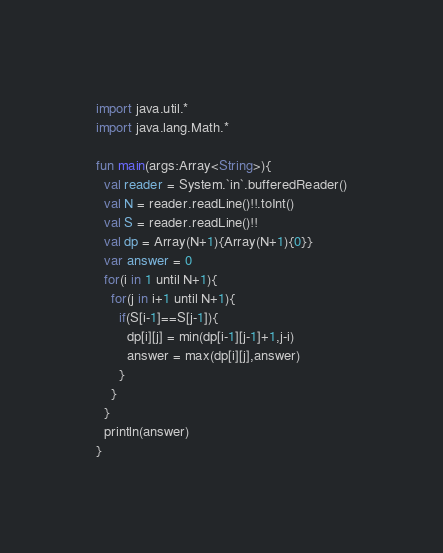<code> <loc_0><loc_0><loc_500><loc_500><_Kotlin_>import java.util.*
import java.lang.Math.*

fun main(args:Array<String>){
  val reader = System.`in`.bufferedReader()
  val N = reader.readLine()!!.toInt()
  val S = reader.readLine()!!
  val dp = Array(N+1){Array(N+1){0}}
  var answer = 0
  for(i in 1 until N+1){
    for(j in i+1 until N+1){
      if(S[i-1]==S[j-1]){
        dp[i][j] = min(dp[i-1][j-1]+1,j-i)
        answer = max(dp[i][j],answer)
      }
    }
  }
  println(answer)
}

</code> 